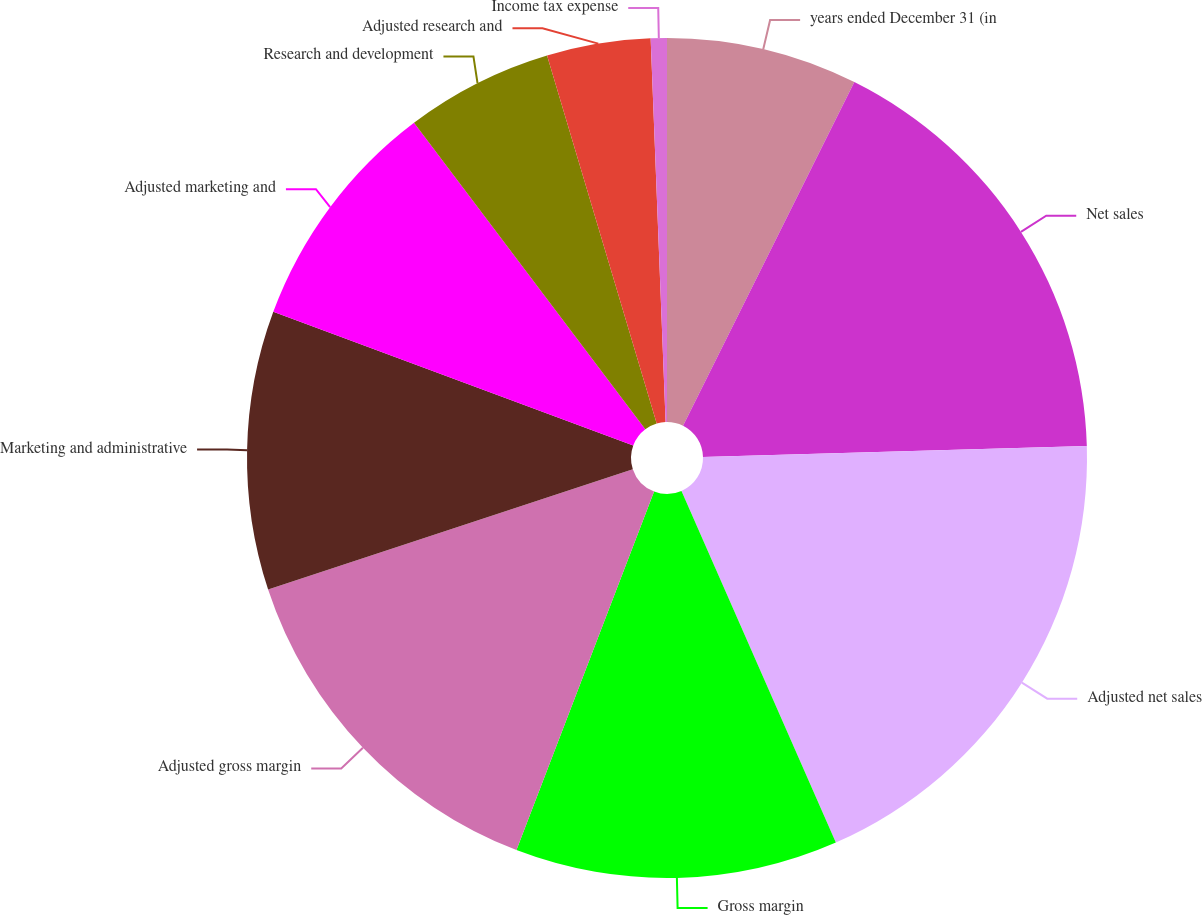Convert chart. <chart><loc_0><loc_0><loc_500><loc_500><pie_chart><fcel>years ended December 31 (in<fcel>Net sales<fcel>Adjusted net sales<fcel>Gross margin<fcel>Adjusted gross margin<fcel>Marketing and administrative<fcel>Adjusted marketing and<fcel>Research and development<fcel>Adjusted research and<fcel>Income tax expense<nl><fcel>7.36%<fcel>17.19%<fcel>18.87%<fcel>12.42%<fcel>14.1%<fcel>10.73%<fcel>9.05%<fcel>5.68%<fcel>3.99%<fcel>0.62%<nl></chart> 